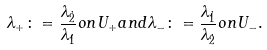<formula> <loc_0><loc_0><loc_500><loc_500>\lambda _ { + } \colon = \frac { \lambda _ { \dot { 2 } } } { \lambda _ { \dot { 1 } } } o n U _ { + } a n d \lambda _ { - } \colon = \frac { \lambda _ { \dot { 1 } } } { \lambda _ { \dot { 2 } } } o n U _ { - } .</formula> 